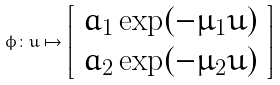Convert formula to latex. <formula><loc_0><loc_0><loc_500><loc_500>\phi \colon u \mapsto \left [ \begin{array} { c } a _ { 1 } \exp ( - \mu _ { 1 } u ) \\ a _ { 2 } \exp ( - \mu _ { 2 } u ) \end{array} \right ]</formula> 